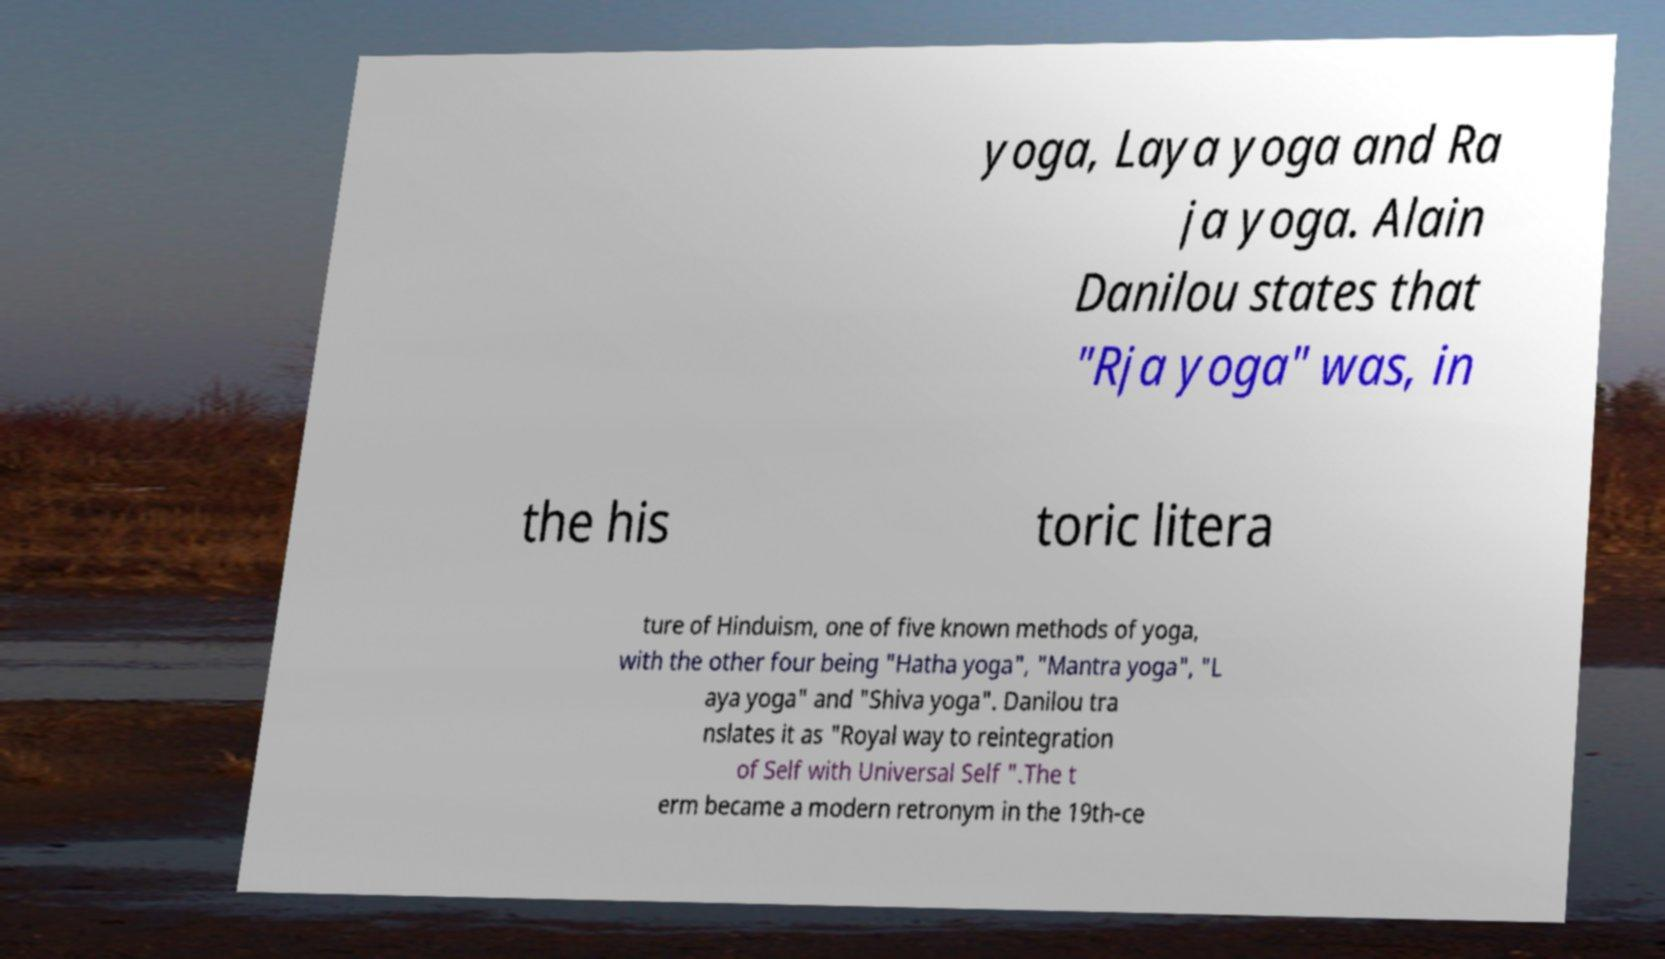Could you assist in decoding the text presented in this image and type it out clearly? yoga, Laya yoga and Ra ja yoga. Alain Danilou states that "Rja yoga" was, in the his toric litera ture of Hinduism, one of five known methods of yoga, with the other four being "Hatha yoga", "Mantra yoga", "L aya yoga" and "Shiva yoga". Danilou tra nslates it as "Royal way to reintegration of Self with Universal Self ".The t erm became a modern retronym in the 19th-ce 